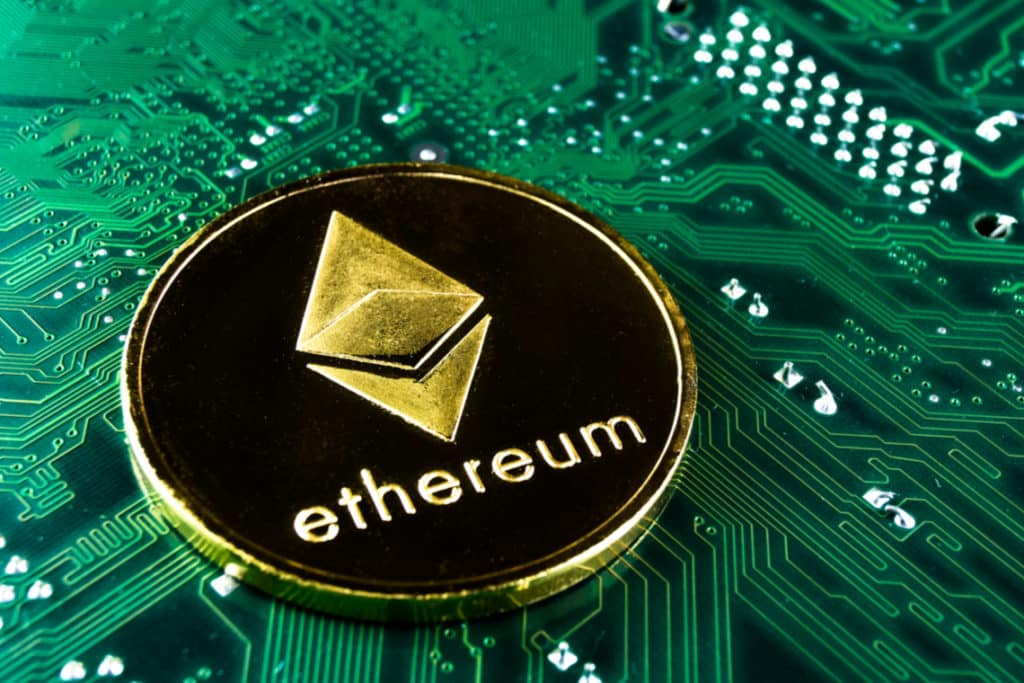How can this image inspire the narrative for a science fiction novel? This image could serve as the cornerstone for a riveting science fiction narrative centered around a world where digital currencies and advanced technologies have become indistinguishable. In this tale, society has evolved into a tech-dominated landscape where cryptocurrencies like Ethereum form the backbone of an entirely digital economy. Our protagonist, a tech-savvy auditor, discovers a conspiracy where a rogue faction manipulates blockchain systems through hidden circuits embedded in everyday devices. This discovery plunges them into a high-stakes mission across high-tech cities and hidden underground facilities to prevent an impending financial collapse engineered by this faction. The circuit board and Ethereum coin symbolize the duality of trust and vulnerability in a tech-integrated future, driving the plot towards a thrilling climax. 